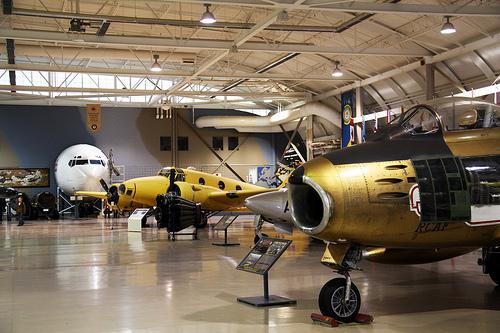Question: what color is the closest plane?
Choices:
A. Silver.
B. Grey.
C. White.
D. Gold and black.
Answer with the letter. Answer: D Question: what kind of flooring is in here?
Choices:
A. Wood.
B. Concrete.
C. Gravel.
D. Plastic.
Answer with the letter. Answer: B 